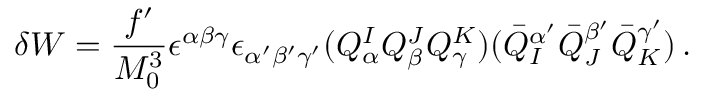Convert formula to latex. <formula><loc_0><loc_0><loc_500><loc_500>\delta W = \frac { f ^ { \prime } } { M _ { 0 } ^ { 3 } } \epsilon ^ { \alpha \beta \gamma } \epsilon _ { \alpha ^ { \prime } \beta ^ { \prime } \gamma ^ { \prime } } ( Q _ { \alpha } ^ { I } Q _ { \beta } ^ { J } Q _ { \gamma } ^ { K } ) ( \bar { Q } _ { I } ^ { \alpha ^ { \prime } } \bar { Q } _ { J } ^ { \beta ^ { \prime } } \bar { Q } _ { K } ^ { \gamma ^ { \prime } } ) \, .</formula> 